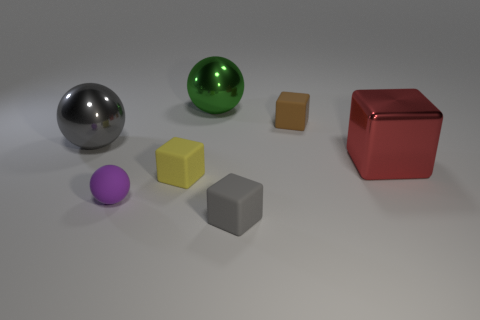There is a large metal thing that is to the right of the tiny gray rubber block; is it the same color as the tiny matte sphere?
Make the answer very short. No. The red metallic thing that is the same shape as the tiny brown thing is what size?
Offer a terse response. Large. How many large gray objects have the same material as the purple sphere?
Make the answer very short. 0. Is there a yellow thing that is behind the big object to the left of the big sphere that is behind the large gray sphere?
Your answer should be very brief. No. What is the shape of the red object?
Give a very brief answer. Cube. Do the big thing that is right of the small brown rubber thing and the block that is behind the gray sphere have the same material?
Provide a succinct answer. No. What is the shape of the large object that is both to the right of the small yellow rubber thing and in front of the big green shiny sphere?
Your answer should be compact. Cube. The big metallic object that is on the left side of the brown object and in front of the brown cube is what color?
Your response must be concise. Gray. Are there more big cubes that are behind the large green shiny thing than tiny gray objects that are behind the red shiny thing?
Provide a succinct answer. No. There is a metal sphere that is left of the big green object; what color is it?
Offer a terse response. Gray. 